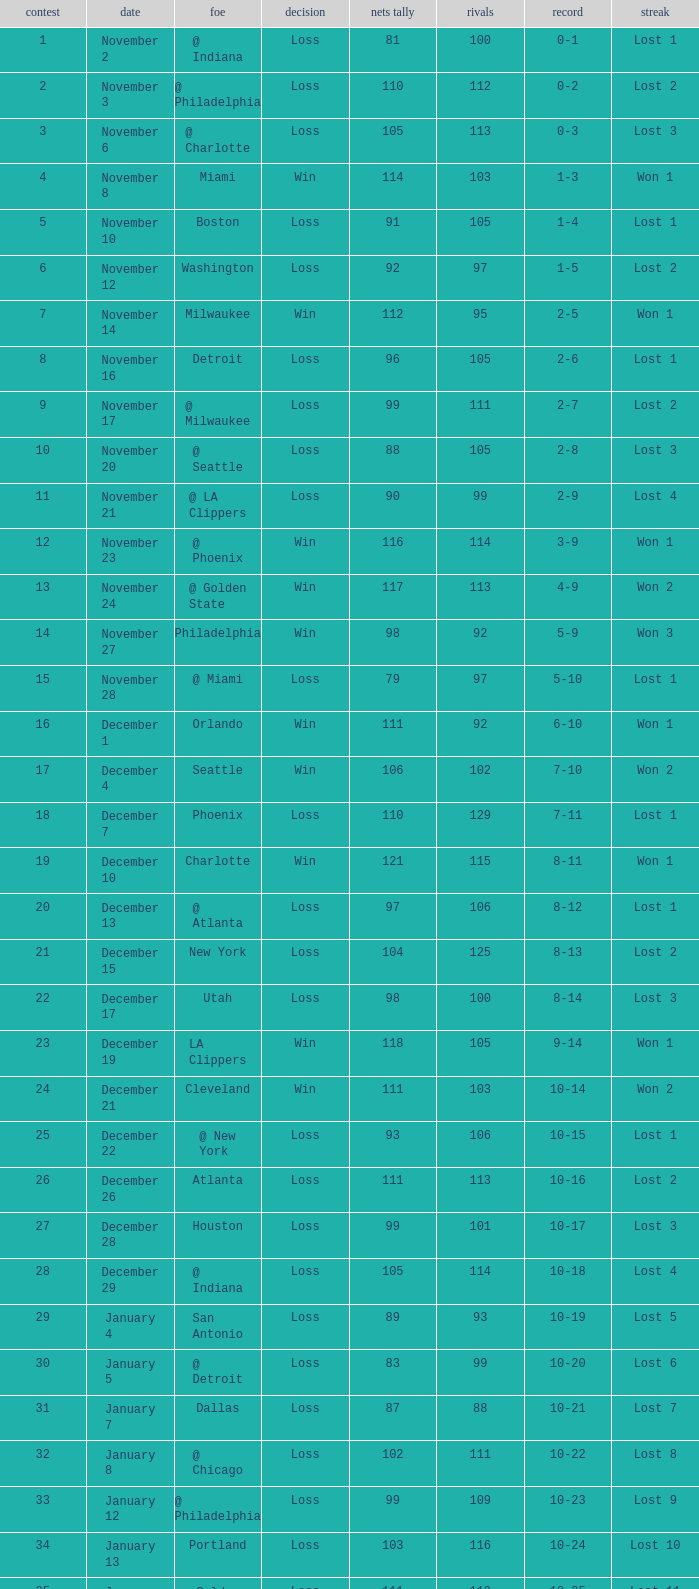What was the average point total for the nets in games before game 9 where the opponents scored less than 95? None. 